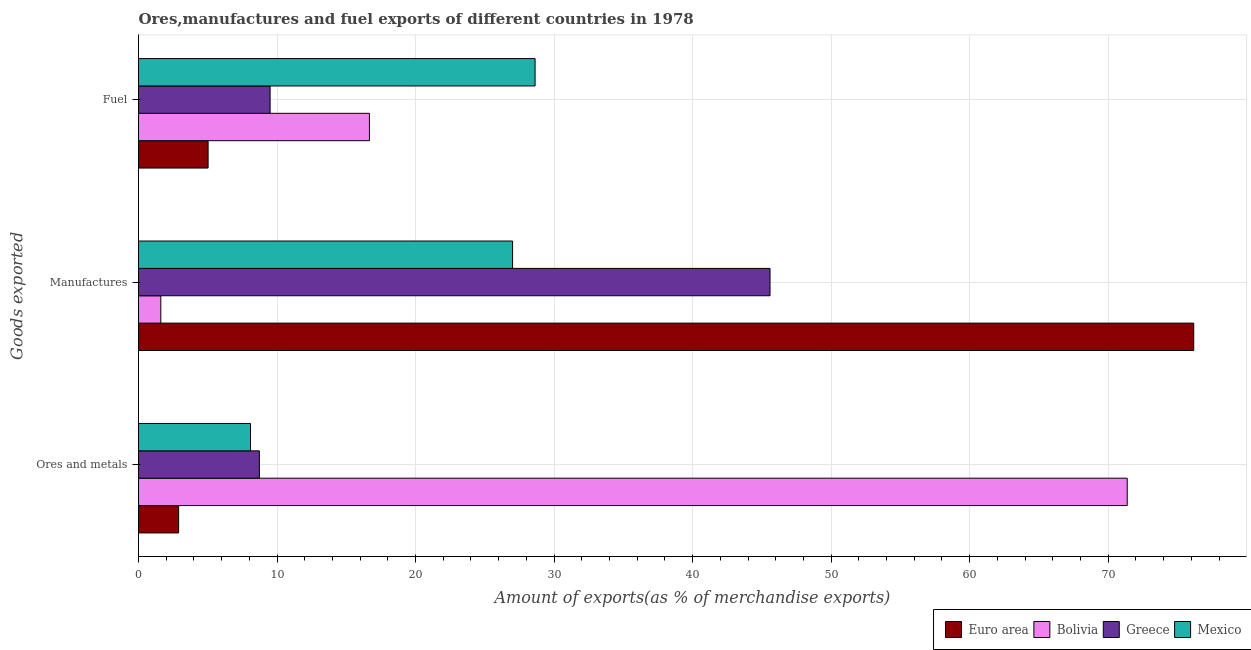How many bars are there on the 3rd tick from the top?
Offer a terse response. 4. What is the label of the 1st group of bars from the top?
Offer a very short reply. Fuel. What is the percentage of fuel exports in Greece?
Give a very brief answer. 9.5. Across all countries, what is the maximum percentage of ores and metals exports?
Your answer should be compact. 71.37. Across all countries, what is the minimum percentage of manufactures exports?
Ensure brevity in your answer.  1.61. In which country was the percentage of fuel exports maximum?
Your answer should be compact. Mexico. In which country was the percentage of manufactures exports minimum?
Ensure brevity in your answer.  Bolivia. What is the total percentage of fuel exports in the graph?
Offer a very short reply. 59.82. What is the difference between the percentage of ores and metals exports in Greece and that in Bolivia?
Ensure brevity in your answer.  -62.65. What is the difference between the percentage of fuel exports in Euro area and the percentage of ores and metals exports in Greece?
Offer a very short reply. -3.7. What is the average percentage of fuel exports per country?
Provide a succinct answer. 14.96. What is the difference between the percentage of ores and metals exports and percentage of fuel exports in Bolivia?
Make the answer very short. 54.7. In how many countries, is the percentage of manufactures exports greater than 8 %?
Your answer should be very brief. 3. What is the ratio of the percentage of ores and metals exports in Bolivia to that in Greece?
Make the answer very short. 8.18. What is the difference between the highest and the second highest percentage of manufactures exports?
Make the answer very short. 30.59. What is the difference between the highest and the lowest percentage of manufactures exports?
Keep it short and to the point. 74.57. In how many countries, is the percentage of manufactures exports greater than the average percentage of manufactures exports taken over all countries?
Provide a short and direct response. 2. Is the sum of the percentage of fuel exports in Greece and Euro area greater than the maximum percentage of manufactures exports across all countries?
Your response must be concise. No. What does the 1st bar from the top in Ores and metals represents?
Your answer should be very brief. Mexico. How many bars are there?
Your answer should be compact. 12. Are all the bars in the graph horizontal?
Give a very brief answer. Yes. How many countries are there in the graph?
Offer a terse response. 4. Are the values on the major ticks of X-axis written in scientific E-notation?
Your response must be concise. No. Does the graph contain any zero values?
Your answer should be very brief. No. Where does the legend appear in the graph?
Ensure brevity in your answer.  Bottom right. How many legend labels are there?
Make the answer very short. 4. What is the title of the graph?
Keep it short and to the point. Ores,manufactures and fuel exports of different countries in 1978. Does "Jamaica" appear as one of the legend labels in the graph?
Provide a short and direct response. No. What is the label or title of the X-axis?
Your response must be concise. Amount of exports(as % of merchandise exports). What is the label or title of the Y-axis?
Ensure brevity in your answer.  Goods exported. What is the Amount of exports(as % of merchandise exports) of Euro area in Ores and metals?
Offer a very short reply. 2.9. What is the Amount of exports(as % of merchandise exports) in Bolivia in Ores and metals?
Offer a terse response. 71.37. What is the Amount of exports(as % of merchandise exports) of Greece in Ores and metals?
Ensure brevity in your answer.  8.73. What is the Amount of exports(as % of merchandise exports) in Mexico in Ores and metals?
Provide a succinct answer. 8.09. What is the Amount of exports(as % of merchandise exports) of Euro area in Manufactures?
Your response must be concise. 76.18. What is the Amount of exports(as % of merchandise exports) in Bolivia in Manufactures?
Ensure brevity in your answer.  1.61. What is the Amount of exports(as % of merchandise exports) in Greece in Manufactures?
Your response must be concise. 45.59. What is the Amount of exports(as % of merchandise exports) of Mexico in Manufactures?
Make the answer very short. 27. What is the Amount of exports(as % of merchandise exports) in Euro area in Fuel?
Make the answer very short. 5.02. What is the Amount of exports(as % of merchandise exports) of Bolivia in Fuel?
Your response must be concise. 16.67. What is the Amount of exports(as % of merchandise exports) in Greece in Fuel?
Give a very brief answer. 9.5. What is the Amount of exports(as % of merchandise exports) of Mexico in Fuel?
Provide a succinct answer. 28.63. Across all Goods exported, what is the maximum Amount of exports(as % of merchandise exports) in Euro area?
Offer a terse response. 76.18. Across all Goods exported, what is the maximum Amount of exports(as % of merchandise exports) in Bolivia?
Provide a short and direct response. 71.37. Across all Goods exported, what is the maximum Amount of exports(as % of merchandise exports) of Greece?
Your answer should be compact. 45.59. Across all Goods exported, what is the maximum Amount of exports(as % of merchandise exports) in Mexico?
Ensure brevity in your answer.  28.63. Across all Goods exported, what is the minimum Amount of exports(as % of merchandise exports) in Euro area?
Your answer should be compact. 2.9. Across all Goods exported, what is the minimum Amount of exports(as % of merchandise exports) in Bolivia?
Make the answer very short. 1.61. Across all Goods exported, what is the minimum Amount of exports(as % of merchandise exports) in Greece?
Give a very brief answer. 8.73. Across all Goods exported, what is the minimum Amount of exports(as % of merchandise exports) of Mexico?
Your response must be concise. 8.09. What is the total Amount of exports(as % of merchandise exports) in Euro area in the graph?
Your answer should be compact. 84.1. What is the total Amount of exports(as % of merchandise exports) of Bolivia in the graph?
Your answer should be compact. 89.65. What is the total Amount of exports(as % of merchandise exports) of Greece in the graph?
Your response must be concise. 63.82. What is the total Amount of exports(as % of merchandise exports) in Mexico in the graph?
Ensure brevity in your answer.  63.72. What is the difference between the Amount of exports(as % of merchandise exports) of Euro area in Ores and metals and that in Manufactures?
Keep it short and to the point. -73.28. What is the difference between the Amount of exports(as % of merchandise exports) in Bolivia in Ores and metals and that in Manufactures?
Keep it short and to the point. 69.76. What is the difference between the Amount of exports(as % of merchandise exports) of Greece in Ores and metals and that in Manufactures?
Keep it short and to the point. -36.86. What is the difference between the Amount of exports(as % of merchandise exports) in Mexico in Ores and metals and that in Manufactures?
Keep it short and to the point. -18.92. What is the difference between the Amount of exports(as % of merchandise exports) in Euro area in Ores and metals and that in Fuel?
Make the answer very short. -2.13. What is the difference between the Amount of exports(as % of merchandise exports) in Bolivia in Ores and metals and that in Fuel?
Offer a very short reply. 54.7. What is the difference between the Amount of exports(as % of merchandise exports) of Greece in Ores and metals and that in Fuel?
Offer a terse response. -0.77. What is the difference between the Amount of exports(as % of merchandise exports) of Mexico in Ores and metals and that in Fuel?
Give a very brief answer. -20.54. What is the difference between the Amount of exports(as % of merchandise exports) in Euro area in Manufactures and that in Fuel?
Your answer should be compact. 71.15. What is the difference between the Amount of exports(as % of merchandise exports) of Bolivia in Manufactures and that in Fuel?
Provide a succinct answer. -15.06. What is the difference between the Amount of exports(as % of merchandise exports) of Greece in Manufactures and that in Fuel?
Offer a very short reply. 36.09. What is the difference between the Amount of exports(as % of merchandise exports) in Mexico in Manufactures and that in Fuel?
Your answer should be compact. -1.62. What is the difference between the Amount of exports(as % of merchandise exports) of Euro area in Ores and metals and the Amount of exports(as % of merchandise exports) of Bolivia in Manufactures?
Provide a short and direct response. 1.29. What is the difference between the Amount of exports(as % of merchandise exports) of Euro area in Ores and metals and the Amount of exports(as % of merchandise exports) of Greece in Manufactures?
Ensure brevity in your answer.  -42.69. What is the difference between the Amount of exports(as % of merchandise exports) in Euro area in Ores and metals and the Amount of exports(as % of merchandise exports) in Mexico in Manufactures?
Your answer should be compact. -24.11. What is the difference between the Amount of exports(as % of merchandise exports) of Bolivia in Ores and metals and the Amount of exports(as % of merchandise exports) of Greece in Manufactures?
Ensure brevity in your answer.  25.78. What is the difference between the Amount of exports(as % of merchandise exports) of Bolivia in Ores and metals and the Amount of exports(as % of merchandise exports) of Mexico in Manufactures?
Keep it short and to the point. 44.37. What is the difference between the Amount of exports(as % of merchandise exports) of Greece in Ores and metals and the Amount of exports(as % of merchandise exports) of Mexico in Manufactures?
Your answer should be very brief. -18.28. What is the difference between the Amount of exports(as % of merchandise exports) in Euro area in Ores and metals and the Amount of exports(as % of merchandise exports) in Bolivia in Fuel?
Make the answer very short. -13.77. What is the difference between the Amount of exports(as % of merchandise exports) in Euro area in Ores and metals and the Amount of exports(as % of merchandise exports) in Greece in Fuel?
Provide a succinct answer. -6.6. What is the difference between the Amount of exports(as % of merchandise exports) in Euro area in Ores and metals and the Amount of exports(as % of merchandise exports) in Mexico in Fuel?
Your response must be concise. -25.73. What is the difference between the Amount of exports(as % of merchandise exports) in Bolivia in Ores and metals and the Amount of exports(as % of merchandise exports) in Greece in Fuel?
Your answer should be very brief. 61.87. What is the difference between the Amount of exports(as % of merchandise exports) in Bolivia in Ores and metals and the Amount of exports(as % of merchandise exports) in Mexico in Fuel?
Your answer should be compact. 42.74. What is the difference between the Amount of exports(as % of merchandise exports) in Greece in Ores and metals and the Amount of exports(as % of merchandise exports) in Mexico in Fuel?
Ensure brevity in your answer.  -19.9. What is the difference between the Amount of exports(as % of merchandise exports) in Euro area in Manufactures and the Amount of exports(as % of merchandise exports) in Bolivia in Fuel?
Your response must be concise. 59.5. What is the difference between the Amount of exports(as % of merchandise exports) in Euro area in Manufactures and the Amount of exports(as % of merchandise exports) in Greece in Fuel?
Offer a terse response. 66.68. What is the difference between the Amount of exports(as % of merchandise exports) in Euro area in Manufactures and the Amount of exports(as % of merchandise exports) in Mexico in Fuel?
Ensure brevity in your answer.  47.55. What is the difference between the Amount of exports(as % of merchandise exports) in Bolivia in Manufactures and the Amount of exports(as % of merchandise exports) in Greece in Fuel?
Keep it short and to the point. -7.89. What is the difference between the Amount of exports(as % of merchandise exports) in Bolivia in Manufactures and the Amount of exports(as % of merchandise exports) in Mexico in Fuel?
Provide a succinct answer. -27.02. What is the difference between the Amount of exports(as % of merchandise exports) of Greece in Manufactures and the Amount of exports(as % of merchandise exports) of Mexico in Fuel?
Make the answer very short. 16.96. What is the average Amount of exports(as % of merchandise exports) of Euro area per Goods exported?
Make the answer very short. 28.03. What is the average Amount of exports(as % of merchandise exports) of Bolivia per Goods exported?
Ensure brevity in your answer.  29.88. What is the average Amount of exports(as % of merchandise exports) of Greece per Goods exported?
Your answer should be very brief. 21.27. What is the average Amount of exports(as % of merchandise exports) of Mexico per Goods exported?
Give a very brief answer. 21.24. What is the difference between the Amount of exports(as % of merchandise exports) of Euro area and Amount of exports(as % of merchandise exports) of Bolivia in Ores and metals?
Your response must be concise. -68.48. What is the difference between the Amount of exports(as % of merchandise exports) in Euro area and Amount of exports(as % of merchandise exports) in Greece in Ores and metals?
Offer a very short reply. -5.83. What is the difference between the Amount of exports(as % of merchandise exports) in Euro area and Amount of exports(as % of merchandise exports) in Mexico in Ores and metals?
Offer a terse response. -5.19. What is the difference between the Amount of exports(as % of merchandise exports) in Bolivia and Amount of exports(as % of merchandise exports) in Greece in Ores and metals?
Make the answer very short. 62.65. What is the difference between the Amount of exports(as % of merchandise exports) of Bolivia and Amount of exports(as % of merchandise exports) of Mexico in Ores and metals?
Keep it short and to the point. 63.29. What is the difference between the Amount of exports(as % of merchandise exports) in Greece and Amount of exports(as % of merchandise exports) in Mexico in Ores and metals?
Provide a short and direct response. 0.64. What is the difference between the Amount of exports(as % of merchandise exports) of Euro area and Amount of exports(as % of merchandise exports) of Bolivia in Manufactures?
Make the answer very short. 74.57. What is the difference between the Amount of exports(as % of merchandise exports) in Euro area and Amount of exports(as % of merchandise exports) in Greece in Manufactures?
Make the answer very short. 30.59. What is the difference between the Amount of exports(as % of merchandise exports) in Euro area and Amount of exports(as % of merchandise exports) in Mexico in Manufactures?
Provide a short and direct response. 49.17. What is the difference between the Amount of exports(as % of merchandise exports) in Bolivia and Amount of exports(as % of merchandise exports) in Greece in Manufactures?
Provide a succinct answer. -43.98. What is the difference between the Amount of exports(as % of merchandise exports) of Bolivia and Amount of exports(as % of merchandise exports) of Mexico in Manufactures?
Ensure brevity in your answer.  -25.39. What is the difference between the Amount of exports(as % of merchandise exports) in Greece and Amount of exports(as % of merchandise exports) in Mexico in Manufactures?
Offer a terse response. 18.58. What is the difference between the Amount of exports(as % of merchandise exports) of Euro area and Amount of exports(as % of merchandise exports) of Bolivia in Fuel?
Offer a very short reply. -11.65. What is the difference between the Amount of exports(as % of merchandise exports) of Euro area and Amount of exports(as % of merchandise exports) of Greece in Fuel?
Give a very brief answer. -4.48. What is the difference between the Amount of exports(as % of merchandise exports) in Euro area and Amount of exports(as % of merchandise exports) in Mexico in Fuel?
Your response must be concise. -23.6. What is the difference between the Amount of exports(as % of merchandise exports) of Bolivia and Amount of exports(as % of merchandise exports) of Greece in Fuel?
Your answer should be very brief. 7.17. What is the difference between the Amount of exports(as % of merchandise exports) in Bolivia and Amount of exports(as % of merchandise exports) in Mexico in Fuel?
Ensure brevity in your answer.  -11.96. What is the difference between the Amount of exports(as % of merchandise exports) of Greece and Amount of exports(as % of merchandise exports) of Mexico in Fuel?
Your response must be concise. -19.13. What is the ratio of the Amount of exports(as % of merchandise exports) in Euro area in Ores and metals to that in Manufactures?
Your answer should be very brief. 0.04. What is the ratio of the Amount of exports(as % of merchandise exports) in Bolivia in Ores and metals to that in Manufactures?
Your answer should be very brief. 44.34. What is the ratio of the Amount of exports(as % of merchandise exports) of Greece in Ores and metals to that in Manufactures?
Your response must be concise. 0.19. What is the ratio of the Amount of exports(as % of merchandise exports) of Mexico in Ores and metals to that in Manufactures?
Offer a terse response. 0.3. What is the ratio of the Amount of exports(as % of merchandise exports) in Euro area in Ores and metals to that in Fuel?
Your response must be concise. 0.58. What is the ratio of the Amount of exports(as % of merchandise exports) of Bolivia in Ores and metals to that in Fuel?
Make the answer very short. 4.28. What is the ratio of the Amount of exports(as % of merchandise exports) of Greece in Ores and metals to that in Fuel?
Give a very brief answer. 0.92. What is the ratio of the Amount of exports(as % of merchandise exports) of Mexico in Ores and metals to that in Fuel?
Ensure brevity in your answer.  0.28. What is the ratio of the Amount of exports(as % of merchandise exports) in Euro area in Manufactures to that in Fuel?
Offer a terse response. 15.16. What is the ratio of the Amount of exports(as % of merchandise exports) in Bolivia in Manufactures to that in Fuel?
Give a very brief answer. 0.1. What is the ratio of the Amount of exports(as % of merchandise exports) in Greece in Manufactures to that in Fuel?
Keep it short and to the point. 4.8. What is the ratio of the Amount of exports(as % of merchandise exports) in Mexico in Manufactures to that in Fuel?
Your answer should be very brief. 0.94. What is the difference between the highest and the second highest Amount of exports(as % of merchandise exports) of Euro area?
Your answer should be very brief. 71.15. What is the difference between the highest and the second highest Amount of exports(as % of merchandise exports) of Bolivia?
Provide a succinct answer. 54.7. What is the difference between the highest and the second highest Amount of exports(as % of merchandise exports) in Greece?
Your answer should be compact. 36.09. What is the difference between the highest and the second highest Amount of exports(as % of merchandise exports) in Mexico?
Your answer should be compact. 1.62. What is the difference between the highest and the lowest Amount of exports(as % of merchandise exports) in Euro area?
Give a very brief answer. 73.28. What is the difference between the highest and the lowest Amount of exports(as % of merchandise exports) of Bolivia?
Your response must be concise. 69.76. What is the difference between the highest and the lowest Amount of exports(as % of merchandise exports) of Greece?
Make the answer very short. 36.86. What is the difference between the highest and the lowest Amount of exports(as % of merchandise exports) of Mexico?
Provide a short and direct response. 20.54. 